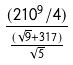Convert formula to latex. <formula><loc_0><loc_0><loc_500><loc_500>\frac { ( 2 1 0 ^ { 9 } / 4 ) } { \frac { ( \sqrt { 9 } + 3 1 7 ) } { \sqrt { 5 } } }</formula> 